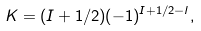<formula> <loc_0><loc_0><loc_500><loc_500>K = ( I + 1 / 2 ) ( - 1 ) ^ { I + 1 / 2 - l } ,</formula> 